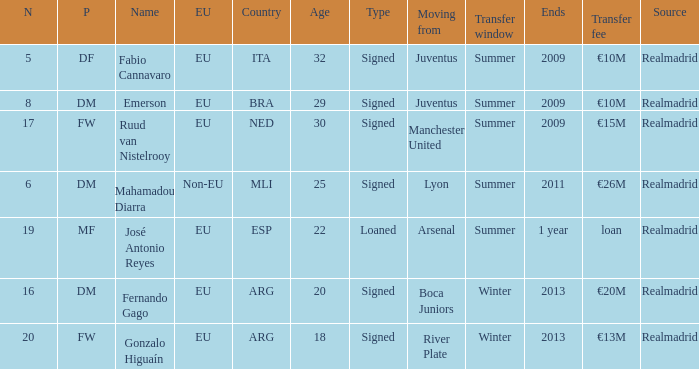What kind of player had a transfer fee of €20m? Signed. Would you be able to parse every entry in this table? {'header': ['N', 'P', 'Name', 'EU', 'Country', 'Age', 'Type', 'Moving from', 'Transfer window', 'Ends', 'Transfer fee', 'Source'], 'rows': [['5', 'DF', 'Fabio Cannavaro', 'EU', 'ITA', '32', 'Signed', 'Juventus', 'Summer', '2009', '€10M', 'Realmadrid'], ['8', 'DM', 'Emerson', 'EU', 'BRA', '29', 'Signed', 'Juventus', 'Summer', '2009', '€10M', 'Realmadrid'], ['17', 'FW', 'Ruud van Nistelrooy', 'EU', 'NED', '30', 'Signed', 'Manchester United', 'Summer', '2009', '€15M', 'Realmadrid'], ['6', 'DM', 'Mahamadou Diarra', 'Non-EU', 'MLI', '25', 'Signed', 'Lyon', 'Summer', '2011', '€26M', 'Realmadrid'], ['19', 'MF', 'José Antonio Reyes', 'EU', 'ESP', '22', 'Loaned', 'Arsenal', 'Summer', '1 year', 'loan', 'Realmadrid'], ['16', 'DM', 'Fernando Gago', 'EU', 'ARG', '20', 'Signed', 'Boca Juniors', 'Winter', '2013', '€20M', 'Realmadrid'], ['20', 'FW', 'Gonzalo Higuaín', 'EU', 'ARG', '18', 'Signed', 'River Plate', 'Winter', '2013', '€13M', 'Realmadrid']]} 